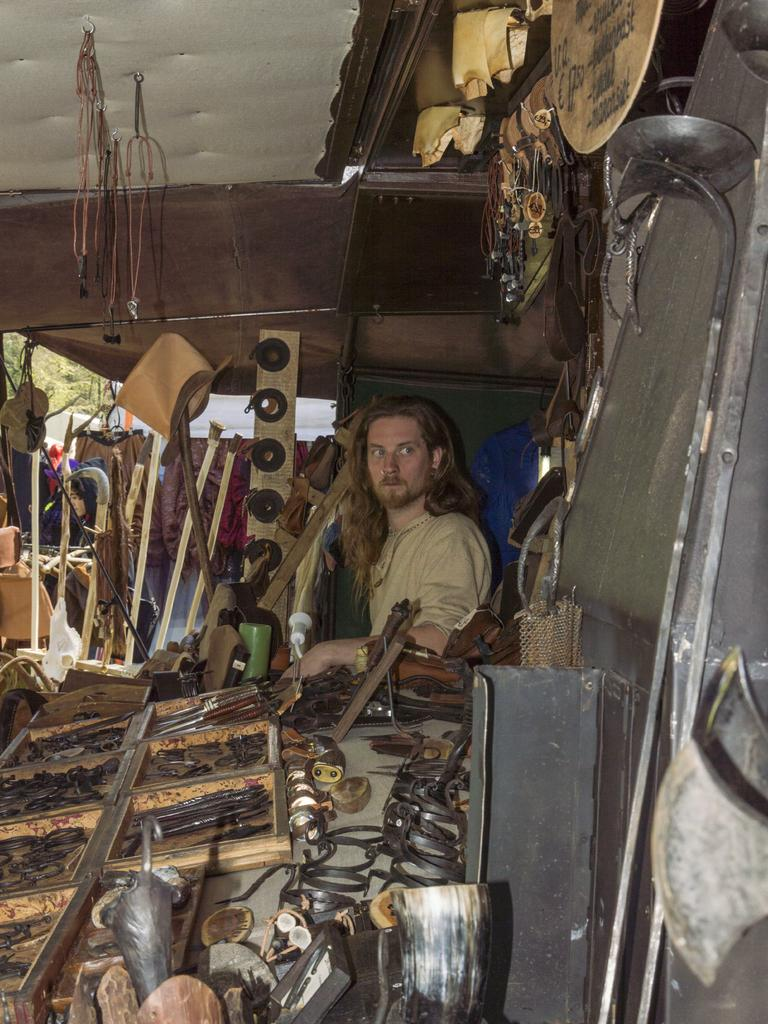Who or what is present in the image? There is a person in the image. What items can be seen that are typically used for work or construction? There are tools, rods, and sticks in the image. What type of clothing is visible in the image? There are clothes in the image. What can be seen in the background of the image? There are trees in the background of the image. What type of wool is being spun by the beast in the image? There is no beast or wool present in the image. How does the dust affect the person's work in the image? There is no dust present in the image, so its effect on the person's work cannot be determined. 